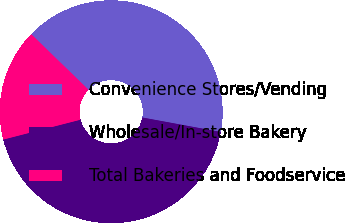Convert chart. <chart><loc_0><loc_0><loc_500><loc_500><pie_chart><fcel>Convenience Stores/Vending<fcel>Wholesale/In-store Bakery<fcel>Total Bakeries and Foodservice<nl><fcel>40.65%<fcel>43.09%<fcel>16.26%<nl></chart> 